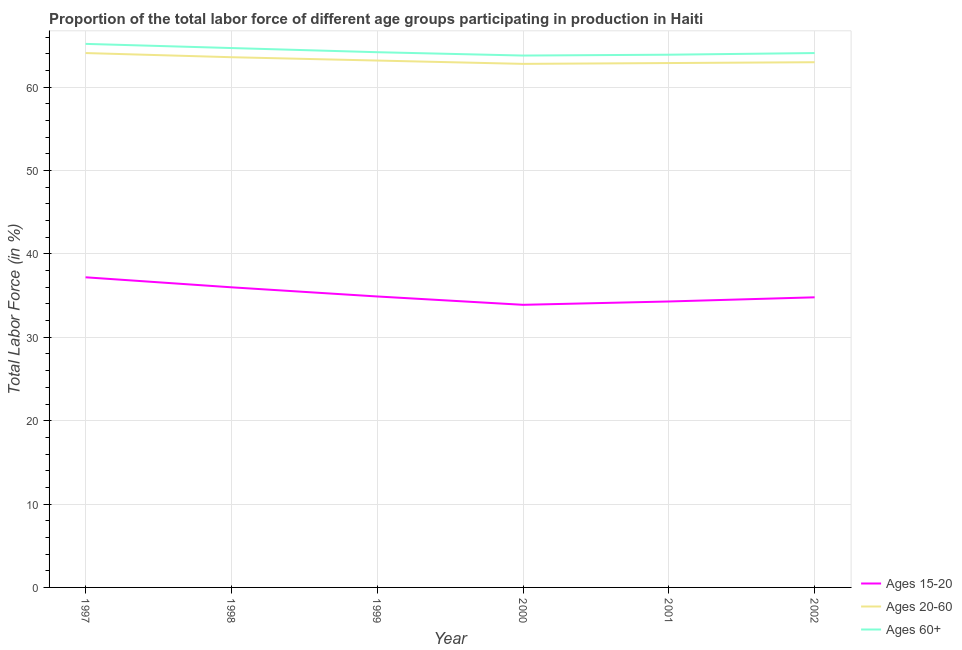Does the line corresponding to percentage of labor force within the age group 15-20 intersect with the line corresponding to percentage of labor force within the age group 20-60?
Ensure brevity in your answer.  No. Is the number of lines equal to the number of legend labels?
Make the answer very short. Yes. What is the percentage of labor force above age 60 in 1999?
Make the answer very short. 64.2. Across all years, what is the maximum percentage of labor force within the age group 20-60?
Offer a very short reply. 64.1. Across all years, what is the minimum percentage of labor force within the age group 20-60?
Offer a terse response. 62.8. In which year was the percentage of labor force above age 60 maximum?
Make the answer very short. 1997. What is the total percentage of labor force within the age group 15-20 in the graph?
Give a very brief answer. 211.1. What is the difference between the percentage of labor force above age 60 in 1997 and that in 2001?
Provide a succinct answer. 1.3. What is the difference between the percentage of labor force within the age group 15-20 in 2001 and the percentage of labor force within the age group 20-60 in 2002?
Make the answer very short. -28.7. What is the average percentage of labor force above age 60 per year?
Provide a succinct answer. 64.32. In the year 2001, what is the difference between the percentage of labor force within the age group 15-20 and percentage of labor force within the age group 20-60?
Your response must be concise. -28.6. What is the ratio of the percentage of labor force above age 60 in 2001 to that in 2002?
Give a very brief answer. 1. Is the percentage of labor force above age 60 in 1998 less than that in 2001?
Your response must be concise. No. Is the difference between the percentage of labor force within the age group 15-20 in 1999 and 2000 greater than the difference between the percentage of labor force within the age group 20-60 in 1999 and 2000?
Offer a terse response. Yes. What is the difference between the highest and the second highest percentage of labor force above age 60?
Make the answer very short. 0.5. What is the difference between the highest and the lowest percentage of labor force within the age group 15-20?
Offer a terse response. 3.3. Is the sum of the percentage of labor force within the age group 15-20 in 1998 and 1999 greater than the maximum percentage of labor force above age 60 across all years?
Offer a terse response. Yes. Is it the case that in every year, the sum of the percentage of labor force within the age group 15-20 and percentage of labor force within the age group 20-60 is greater than the percentage of labor force above age 60?
Ensure brevity in your answer.  Yes. How many lines are there?
Give a very brief answer. 3. Does the graph contain grids?
Make the answer very short. Yes. Where does the legend appear in the graph?
Keep it short and to the point. Bottom right. What is the title of the graph?
Your response must be concise. Proportion of the total labor force of different age groups participating in production in Haiti. What is the label or title of the X-axis?
Make the answer very short. Year. What is the Total Labor Force (in %) of Ages 15-20 in 1997?
Ensure brevity in your answer.  37.2. What is the Total Labor Force (in %) in Ages 20-60 in 1997?
Make the answer very short. 64.1. What is the Total Labor Force (in %) of Ages 60+ in 1997?
Make the answer very short. 65.2. What is the Total Labor Force (in %) in Ages 15-20 in 1998?
Offer a very short reply. 36. What is the Total Labor Force (in %) of Ages 20-60 in 1998?
Provide a short and direct response. 63.6. What is the Total Labor Force (in %) of Ages 60+ in 1998?
Your response must be concise. 64.7. What is the Total Labor Force (in %) in Ages 15-20 in 1999?
Make the answer very short. 34.9. What is the Total Labor Force (in %) in Ages 20-60 in 1999?
Provide a short and direct response. 63.2. What is the Total Labor Force (in %) in Ages 60+ in 1999?
Offer a very short reply. 64.2. What is the Total Labor Force (in %) in Ages 15-20 in 2000?
Ensure brevity in your answer.  33.9. What is the Total Labor Force (in %) of Ages 20-60 in 2000?
Your response must be concise. 62.8. What is the Total Labor Force (in %) of Ages 60+ in 2000?
Your answer should be compact. 63.8. What is the Total Labor Force (in %) of Ages 15-20 in 2001?
Offer a terse response. 34.3. What is the Total Labor Force (in %) of Ages 20-60 in 2001?
Keep it short and to the point. 62.9. What is the Total Labor Force (in %) in Ages 60+ in 2001?
Ensure brevity in your answer.  63.9. What is the Total Labor Force (in %) in Ages 15-20 in 2002?
Provide a succinct answer. 34.8. What is the Total Labor Force (in %) of Ages 20-60 in 2002?
Give a very brief answer. 63. What is the Total Labor Force (in %) in Ages 60+ in 2002?
Provide a short and direct response. 64.1. Across all years, what is the maximum Total Labor Force (in %) of Ages 15-20?
Give a very brief answer. 37.2. Across all years, what is the maximum Total Labor Force (in %) of Ages 20-60?
Your answer should be compact. 64.1. Across all years, what is the maximum Total Labor Force (in %) in Ages 60+?
Provide a short and direct response. 65.2. Across all years, what is the minimum Total Labor Force (in %) in Ages 15-20?
Provide a succinct answer. 33.9. Across all years, what is the minimum Total Labor Force (in %) in Ages 20-60?
Your answer should be very brief. 62.8. Across all years, what is the minimum Total Labor Force (in %) of Ages 60+?
Make the answer very short. 63.8. What is the total Total Labor Force (in %) in Ages 15-20 in the graph?
Keep it short and to the point. 211.1. What is the total Total Labor Force (in %) in Ages 20-60 in the graph?
Ensure brevity in your answer.  379.6. What is the total Total Labor Force (in %) of Ages 60+ in the graph?
Offer a very short reply. 385.9. What is the difference between the Total Labor Force (in %) of Ages 60+ in 1997 and that in 1998?
Your answer should be compact. 0.5. What is the difference between the Total Labor Force (in %) of Ages 15-20 in 1997 and that in 2000?
Your answer should be very brief. 3.3. What is the difference between the Total Labor Force (in %) of Ages 20-60 in 1997 and that in 2000?
Provide a short and direct response. 1.3. What is the difference between the Total Labor Force (in %) of Ages 60+ in 1997 and that in 2000?
Provide a succinct answer. 1.4. What is the difference between the Total Labor Force (in %) in Ages 60+ in 1997 and that in 2001?
Offer a terse response. 1.3. What is the difference between the Total Labor Force (in %) of Ages 15-20 in 1998 and that in 1999?
Your answer should be compact. 1.1. What is the difference between the Total Labor Force (in %) in Ages 20-60 in 1998 and that in 1999?
Offer a very short reply. 0.4. What is the difference between the Total Labor Force (in %) of Ages 15-20 in 1998 and that in 2000?
Keep it short and to the point. 2.1. What is the difference between the Total Labor Force (in %) in Ages 20-60 in 1998 and that in 2000?
Make the answer very short. 0.8. What is the difference between the Total Labor Force (in %) of Ages 60+ in 1998 and that in 2000?
Ensure brevity in your answer.  0.9. What is the difference between the Total Labor Force (in %) of Ages 15-20 in 1998 and that in 2001?
Give a very brief answer. 1.7. What is the difference between the Total Labor Force (in %) in Ages 20-60 in 1998 and that in 2001?
Ensure brevity in your answer.  0.7. What is the difference between the Total Labor Force (in %) of Ages 15-20 in 1998 and that in 2002?
Keep it short and to the point. 1.2. What is the difference between the Total Labor Force (in %) in Ages 60+ in 1998 and that in 2002?
Ensure brevity in your answer.  0.6. What is the difference between the Total Labor Force (in %) of Ages 20-60 in 1999 and that in 2000?
Your response must be concise. 0.4. What is the difference between the Total Labor Force (in %) of Ages 15-20 in 1999 and that in 2001?
Give a very brief answer. 0.6. What is the difference between the Total Labor Force (in %) in Ages 20-60 in 1999 and that in 2001?
Ensure brevity in your answer.  0.3. What is the difference between the Total Labor Force (in %) of Ages 60+ in 1999 and that in 2001?
Give a very brief answer. 0.3. What is the difference between the Total Labor Force (in %) of Ages 20-60 in 1999 and that in 2002?
Your answer should be compact. 0.2. What is the difference between the Total Labor Force (in %) of Ages 60+ in 1999 and that in 2002?
Provide a short and direct response. 0.1. What is the difference between the Total Labor Force (in %) of Ages 20-60 in 2000 and that in 2001?
Offer a terse response. -0.1. What is the difference between the Total Labor Force (in %) of Ages 15-20 in 2000 and that in 2002?
Provide a succinct answer. -0.9. What is the difference between the Total Labor Force (in %) of Ages 15-20 in 2001 and that in 2002?
Your response must be concise. -0.5. What is the difference between the Total Labor Force (in %) in Ages 20-60 in 2001 and that in 2002?
Provide a succinct answer. -0.1. What is the difference between the Total Labor Force (in %) of Ages 15-20 in 1997 and the Total Labor Force (in %) of Ages 20-60 in 1998?
Your answer should be compact. -26.4. What is the difference between the Total Labor Force (in %) of Ages 15-20 in 1997 and the Total Labor Force (in %) of Ages 60+ in 1998?
Provide a short and direct response. -27.5. What is the difference between the Total Labor Force (in %) in Ages 20-60 in 1997 and the Total Labor Force (in %) in Ages 60+ in 1999?
Keep it short and to the point. -0.1. What is the difference between the Total Labor Force (in %) in Ages 15-20 in 1997 and the Total Labor Force (in %) in Ages 20-60 in 2000?
Your response must be concise. -25.6. What is the difference between the Total Labor Force (in %) in Ages 15-20 in 1997 and the Total Labor Force (in %) in Ages 60+ in 2000?
Make the answer very short. -26.6. What is the difference between the Total Labor Force (in %) in Ages 20-60 in 1997 and the Total Labor Force (in %) in Ages 60+ in 2000?
Provide a succinct answer. 0.3. What is the difference between the Total Labor Force (in %) in Ages 15-20 in 1997 and the Total Labor Force (in %) in Ages 20-60 in 2001?
Give a very brief answer. -25.7. What is the difference between the Total Labor Force (in %) in Ages 15-20 in 1997 and the Total Labor Force (in %) in Ages 60+ in 2001?
Provide a succinct answer. -26.7. What is the difference between the Total Labor Force (in %) of Ages 15-20 in 1997 and the Total Labor Force (in %) of Ages 20-60 in 2002?
Give a very brief answer. -25.8. What is the difference between the Total Labor Force (in %) of Ages 15-20 in 1997 and the Total Labor Force (in %) of Ages 60+ in 2002?
Ensure brevity in your answer.  -26.9. What is the difference between the Total Labor Force (in %) in Ages 15-20 in 1998 and the Total Labor Force (in %) in Ages 20-60 in 1999?
Offer a terse response. -27.2. What is the difference between the Total Labor Force (in %) in Ages 15-20 in 1998 and the Total Labor Force (in %) in Ages 60+ in 1999?
Your answer should be very brief. -28.2. What is the difference between the Total Labor Force (in %) of Ages 20-60 in 1998 and the Total Labor Force (in %) of Ages 60+ in 1999?
Offer a terse response. -0.6. What is the difference between the Total Labor Force (in %) of Ages 15-20 in 1998 and the Total Labor Force (in %) of Ages 20-60 in 2000?
Your response must be concise. -26.8. What is the difference between the Total Labor Force (in %) in Ages 15-20 in 1998 and the Total Labor Force (in %) in Ages 60+ in 2000?
Make the answer very short. -27.8. What is the difference between the Total Labor Force (in %) in Ages 15-20 in 1998 and the Total Labor Force (in %) in Ages 20-60 in 2001?
Keep it short and to the point. -26.9. What is the difference between the Total Labor Force (in %) of Ages 15-20 in 1998 and the Total Labor Force (in %) of Ages 60+ in 2001?
Your response must be concise. -27.9. What is the difference between the Total Labor Force (in %) of Ages 20-60 in 1998 and the Total Labor Force (in %) of Ages 60+ in 2001?
Give a very brief answer. -0.3. What is the difference between the Total Labor Force (in %) of Ages 15-20 in 1998 and the Total Labor Force (in %) of Ages 60+ in 2002?
Your response must be concise. -28.1. What is the difference between the Total Labor Force (in %) in Ages 15-20 in 1999 and the Total Labor Force (in %) in Ages 20-60 in 2000?
Your answer should be compact. -27.9. What is the difference between the Total Labor Force (in %) of Ages 15-20 in 1999 and the Total Labor Force (in %) of Ages 60+ in 2000?
Your answer should be very brief. -28.9. What is the difference between the Total Labor Force (in %) of Ages 20-60 in 1999 and the Total Labor Force (in %) of Ages 60+ in 2001?
Your answer should be compact. -0.7. What is the difference between the Total Labor Force (in %) in Ages 15-20 in 1999 and the Total Labor Force (in %) in Ages 20-60 in 2002?
Make the answer very short. -28.1. What is the difference between the Total Labor Force (in %) in Ages 15-20 in 1999 and the Total Labor Force (in %) in Ages 60+ in 2002?
Ensure brevity in your answer.  -29.2. What is the difference between the Total Labor Force (in %) in Ages 15-20 in 2000 and the Total Labor Force (in %) in Ages 20-60 in 2001?
Provide a short and direct response. -29. What is the difference between the Total Labor Force (in %) of Ages 15-20 in 2000 and the Total Labor Force (in %) of Ages 60+ in 2001?
Your answer should be very brief. -30. What is the difference between the Total Labor Force (in %) in Ages 15-20 in 2000 and the Total Labor Force (in %) in Ages 20-60 in 2002?
Your answer should be compact. -29.1. What is the difference between the Total Labor Force (in %) in Ages 15-20 in 2000 and the Total Labor Force (in %) in Ages 60+ in 2002?
Offer a terse response. -30.2. What is the difference between the Total Labor Force (in %) of Ages 15-20 in 2001 and the Total Labor Force (in %) of Ages 20-60 in 2002?
Offer a terse response. -28.7. What is the difference between the Total Labor Force (in %) in Ages 15-20 in 2001 and the Total Labor Force (in %) in Ages 60+ in 2002?
Your answer should be very brief. -29.8. What is the difference between the Total Labor Force (in %) of Ages 20-60 in 2001 and the Total Labor Force (in %) of Ages 60+ in 2002?
Give a very brief answer. -1.2. What is the average Total Labor Force (in %) in Ages 15-20 per year?
Keep it short and to the point. 35.18. What is the average Total Labor Force (in %) of Ages 20-60 per year?
Provide a succinct answer. 63.27. What is the average Total Labor Force (in %) in Ages 60+ per year?
Your answer should be very brief. 64.32. In the year 1997, what is the difference between the Total Labor Force (in %) of Ages 15-20 and Total Labor Force (in %) of Ages 20-60?
Ensure brevity in your answer.  -26.9. In the year 1997, what is the difference between the Total Labor Force (in %) in Ages 15-20 and Total Labor Force (in %) in Ages 60+?
Keep it short and to the point. -28. In the year 1998, what is the difference between the Total Labor Force (in %) in Ages 15-20 and Total Labor Force (in %) in Ages 20-60?
Your response must be concise. -27.6. In the year 1998, what is the difference between the Total Labor Force (in %) of Ages 15-20 and Total Labor Force (in %) of Ages 60+?
Make the answer very short. -28.7. In the year 1999, what is the difference between the Total Labor Force (in %) of Ages 15-20 and Total Labor Force (in %) of Ages 20-60?
Your answer should be compact. -28.3. In the year 1999, what is the difference between the Total Labor Force (in %) in Ages 15-20 and Total Labor Force (in %) in Ages 60+?
Your answer should be very brief. -29.3. In the year 2000, what is the difference between the Total Labor Force (in %) of Ages 15-20 and Total Labor Force (in %) of Ages 20-60?
Ensure brevity in your answer.  -28.9. In the year 2000, what is the difference between the Total Labor Force (in %) of Ages 15-20 and Total Labor Force (in %) of Ages 60+?
Offer a very short reply. -29.9. In the year 2001, what is the difference between the Total Labor Force (in %) in Ages 15-20 and Total Labor Force (in %) in Ages 20-60?
Provide a short and direct response. -28.6. In the year 2001, what is the difference between the Total Labor Force (in %) of Ages 15-20 and Total Labor Force (in %) of Ages 60+?
Give a very brief answer. -29.6. In the year 2002, what is the difference between the Total Labor Force (in %) in Ages 15-20 and Total Labor Force (in %) in Ages 20-60?
Keep it short and to the point. -28.2. In the year 2002, what is the difference between the Total Labor Force (in %) of Ages 15-20 and Total Labor Force (in %) of Ages 60+?
Give a very brief answer. -29.3. What is the ratio of the Total Labor Force (in %) of Ages 15-20 in 1997 to that in 1998?
Your response must be concise. 1.03. What is the ratio of the Total Labor Force (in %) in Ages 20-60 in 1997 to that in 1998?
Your answer should be compact. 1.01. What is the ratio of the Total Labor Force (in %) of Ages 60+ in 1997 to that in 1998?
Your answer should be very brief. 1.01. What is the ratio of the Total Labor Force (in %) of Ages 15-20 in 1997 to that in 1999?
Your answer should be compact. 1.07. What is the ratio of the Total Labor Force (in %) of Ages 20-60 in 1997 to that in 1999?
Your response must be concise. 1.01. What is the ratio of the Total Labor Force (in %) of Ages 60+ in 1997 to that in 1999?
Provide a short and direct response. 1.02. What is the ratio of the Total Labor Force (in %) of Ages 15-20 in 1997 to that in 2000?
Keep it short and to the point. 1.1. What is the ratio of the Total Labor Force (in %) of Ages 20-60 in 1997 to that in 2000?
Your answer should be very brief. 1.02. What is the ratio of the Total Labor Force (in %) of Ages 60+ in 1997 to that in 2000?
Ensure brevity in your answer.  1.02. What is the ratio of the Total Labor Force (in %) of Ages 15-20 in 1997 to that in 2001?
Offer a very short reply. 1.08. What is the ratio of the Total Labor Force (in %) of Ages 20-60 in 1997 to that in 2001?
Provide a short and direct response. 1.02. What is the ratio of the Total Labor Force (in %) of Ages 60+ in 1997 to that in 2001?
Give a very brief answer. 1.02. What is the ratio of the Total Labor Force (in %) in Ages 15-20 in 1997 to that in 2002?
Offer a very short reply. 1.07. What is the ratio of the Total Labor Force (in %) in Ages 20-60 in 1997 to that in 2002?
Offer a very short reply. 1.02. What is the ratio of the Total Labor Force (in %) of Ages 60+ in 1997 to that in 2002?
Provide a succinct answer. 1.02. What is the ratio of the Total Labor Force (in %) of Ages 15-20 in 1998 to that in 1999?
Provide a short and direct response. 1.03. What is the ratio of the Total Labor Force (in %) of Ages 60+ in 1998 to that in 1999?
Give a very brief answer. 1.01. What is the ratio of the Total Labor Force (in %) in Ages 15-20 in 1998 to that in 2000?
Your answer should be compact. 1.06. What is the ratio of the Total Labor Force (in %) of Ages 20-60 in 1998 to that in 2000?
Ensure brevity in your answer.  1.01. What is the ratio of the Total Labor Force (in %) of Ages 60+ in 1998 to that in 2000?
Give a very brief answer. 1.01. What is the ratio of the Total Labor Force (in %) of Ages 15-20 in 1998 to that in 2001?
Your answer should be compact. 1.05. What is the ratio of the Total Labor Force (in %) of Ages 20-60 in 1998 to that in 2001?
Provide a short and direct response. 1.01. What is the ratio of the Total Labor Force (in %) of Ages 60+ in 1998 to that in 2001?
Keep it short and to the point. 1.01. What is the ratio of the Total Labor Force (in %) in Ages 15-20 in 1998 to that in 2002?
Offer a terse response. 1.03. What is the ratio of the Total Labor Force (in %) of Ages 20-60 in 1998 to that in 2002?
Make the answer very short. 1.01. What is the ratio of the Total Labor Force (in %) of Ages 60+ in 1998 to that in 2002?
Offer a very short reply. 1.01. What is the ratio of the Total Labor Force (in %) of Ages 15-20 in 1999 to that in 2000?
Provide a short and direct response. 1.03. What is the ratio of the Total Labor Force (in %) in Ages 20-60 in 1999 to that in 2000?
Ensure brevity in your answer.  1.01. What is the ratio of the Total Labor Force (in %) in Ages 15-20 in 1999 to that in 2001?
Give a very brief answer. 1.02. What is the ratio of the Total Labor Force (in %) of Ages 15-20 in 2000 to that in 2001?
Offer a very short reply. 0.99. What is the ratio of the Total Labor Force (in %) in Ages 20-60 in 2000 to that in 2001?
Make the answer very short. 1. What is the ratio of the Total Labor Force (in %) in Ages 60+ in 2000 to that in 2001?
Keep it short and to the point. 1. What is the ratio of the Total Labor Force (in %) of Ages 15-20 in 2000 to that in 2002?
Keep it short and to the point. 0.97. What is the ratio of the Total Labor Force (in %) in Ages 15-20 in 2001 to that in 2002?
Keep it short and to the point. 0.99. What is the ratio of the Total Labor Force (in %) in Ages 20-60 in 2001 to that in 2002?
Offer a terse response. 1. What is the difference between the highest and the second highest Total Labor Force (in %) in Ages 20-60?
Keep it short and to the point. 0.5. What is the difference between the highest and the second highest Total Labor Force (in %) in Ages 60+?
Make the answer very short. 0.5. What is the difference between the highest and the lowest Total Labor Force (in %) of Ages 15-20?
Your answer should be compact. 3.3. 